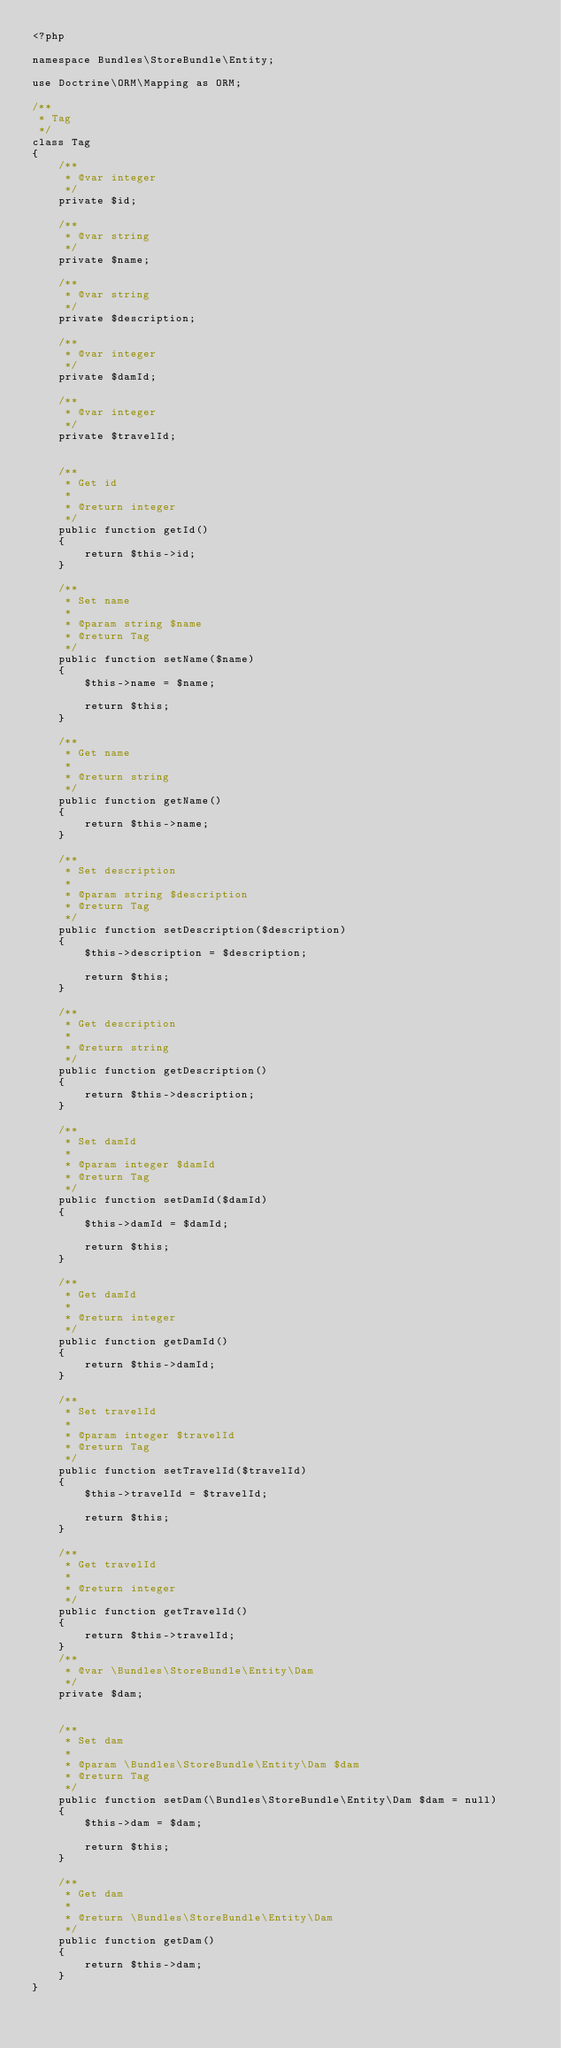Convert code to text. <code><loc_0><loc_0><loc_500><loc_500><_PHP_><?php

namespace Bundles\StoreBundle\Entity;

use Doctrine\ORM\Mapping as ORM;

/**
 * Tag
 */
class Tag
{
    /**
     * @var integer
     */
    private $id;

    /**
     * @var string
     */
    private $name;

    /**
     * @var string
     */
    private $description;

    /**
     * @var integer
     */
    private $damId;

    /**
     * @var integer
     */
    private $travelId;


    /**
     * Get id
     *
     * @return integer 
     */
    public function getId()
    {
        return $this->id;
    }

    /**
     * Set name
     *
     * @param string $name
     * @return Tag
     */
    public function setName($name)
    {
        $this->name = $name;

        return $this;
    }

    /**
     * Get name
     *
     * @return string 
     */
    public function getName()
    {
        return $this->name;
    }

    /**
     * Set description
     *
     * @param string $description
     * @return Tag
     */
    public function setDescription($description)
    {
        $this->description = $description;

        return $this;
    }

    /**
     * Get description
     *
     * @return string 
     */
    public function getDescription()
    {
        return $this->description;
    }

    /**
     * Set damId
     *
     * @param integer $damId
     * @return Tag
     */
    public function setDamId($damId)
    {
        $this->damId = $damId;

        return $this;
    }

    /**
     * Get damId
     *
     * @return integer 
     */
    public function getDamId()
    {
        return $this->damId;
    }

    /**
     * Set travelId
     *
     * @param integer $travelId
     * @return Tag
     */
    public function setTravelId($travelId)
    {
        $this->travelId = $travelId;

        return $this;
    }

    /**
     * Get travelId
     *
     * @return integer 
     */
    public function getTravelId()
    {
        return $this->travelId;
    }
    /**
     * @var \Bundles\StoreBundle\Entity\Dam
     */
    private $dam;


    /**
     * Set dam
     *
     * @param \Bundles\StoreBundle\Entity\Dam $dam
     * @return Tag
     */
    public function setDam(\Bundles\StoreBundle\Entity\Dam $dam = null)
    {
        $this->dam = $dam;

        return $this;
    }

    /**
     * Get dam
     *
     * @return \Bundles\StoreBundle\Entity\Dam 
     */
    public function getDam()
    {
        return $this->dam;
    }
}
</code> 